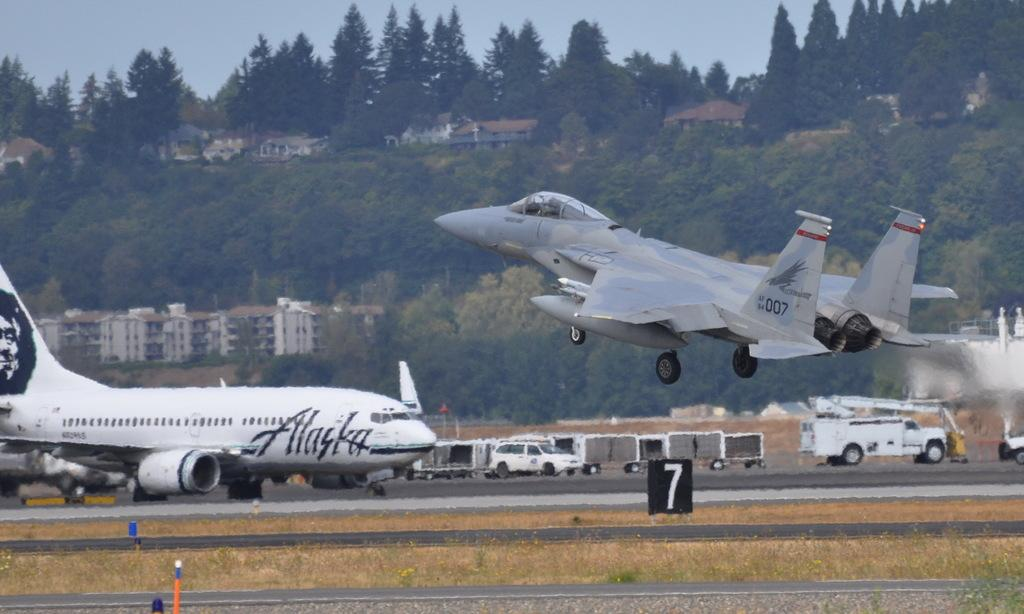<image>
Summarize the visual content of the image. A jet takes off next to an Alaska Airlines plane. 